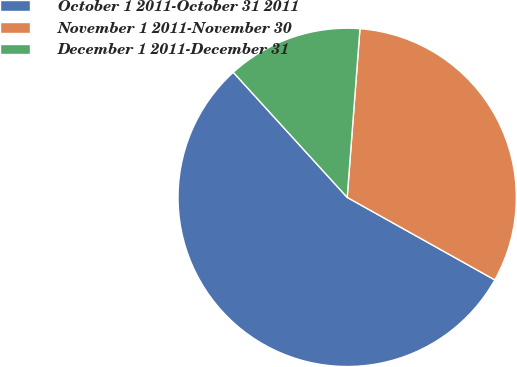Convert chart to OTSL. <chart><loc_0><loc_0><loc_500><loc_500><pie_chart><fcel>October 1 2011-October 31 2011<fcel>November 1 2011-November 30<fcel>December 1 2011-December 31<nl><fcel>55.13%<fcel>31.91%<fcel>12.96%<nl></chart> 